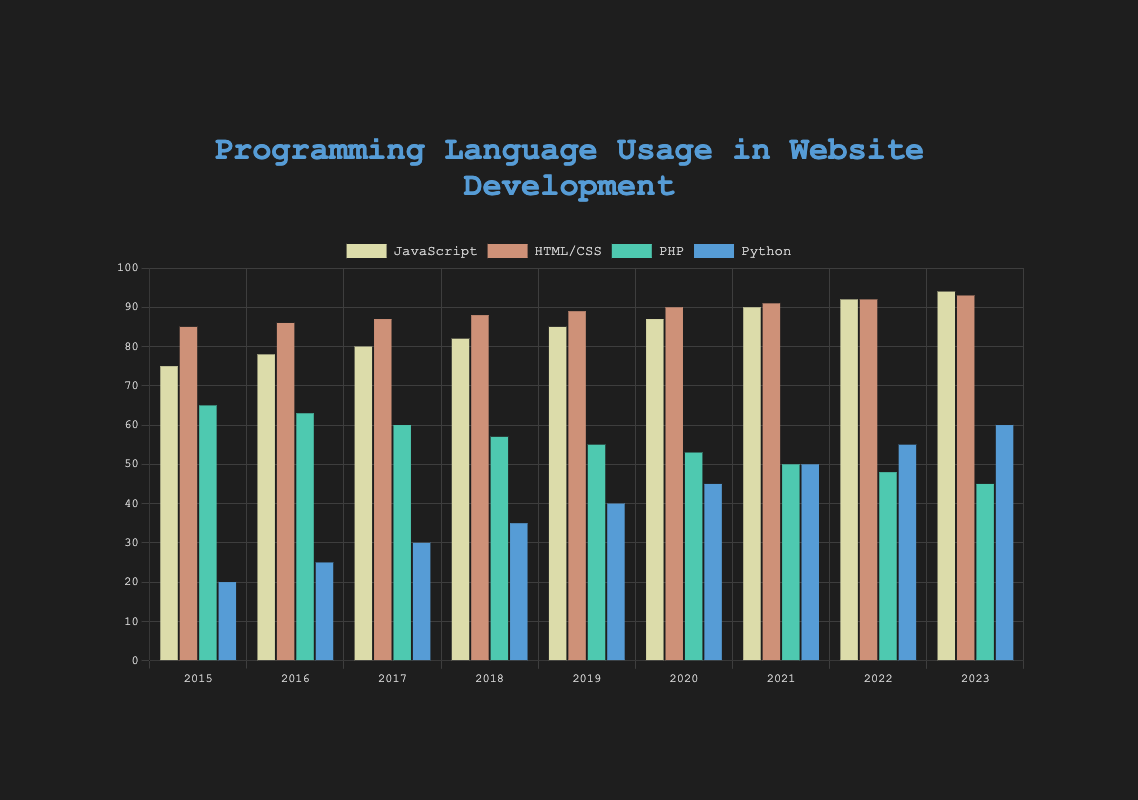What percentage of usage does JavaScript reach in 2023? In 2023, the bar representing JavaScript shows a usage percentage of 94%.
Answer: 94% How did PHP usage change from 2015 to 2023? The PHP usage in 2015 was 65%. In 2023, it decreased to 45%. Therefore, the decrease in PHP usage from 2015 to 2023 is 65% - 45% = 20%.
Answer: Decreased by 20% Between which consecutive years did Python usage see the largest increase? The Python usage increased by 5% each year from 20% in 2015 to 60% in 2023. Between 2020 and 2021, and 2021 and 2022, the increase was consistent at 5%. Thus, each consecutive year saw an equal largest increase of 5%.
Answer: 2015-2016, 2016-2017, 2017-2018, 2018-2019, 2019-2020, 2020-2021, 2021-2022, 2022-2023 (all had equal largest increase) Which language had the highest usage in 2021? In 2021, the heights of the bars show that HTML/CSS had the highest usage at 91%, followed by JavaScript at 90%, PHP at 50%, and Python at 50%. Therefore, HTML/CSS had the highest usage.
Answer: HTML/CSS What is the average usage of JavaScript from 2015 to 2023? To find the average, sum up the JavaScript usage percentages from 2015 to 2023: (75 + 78 + 80 + 82 + 85 + 87 + 90 + 92 + 94) = 763. Now, divide by the number of years (9). The average is 763 / 9 ≈ 84.78%.
Answer: 84.78% How does the usage of HTML/CSS compare between 2015 and 2020? In 2015, HTML/CSS usage was 85%, and in 2020, it increased to 90%. Thus, HTML/CSS usage increased by 90% - 85% = 5% from 2015 to 2020.
Answer: Increased by 5% Which programming language had the least usage in most of the years? By visually inspecting the heights of the bars from 2015 to 2023, it's evident that Python had the least usage in most years until it surpassed PHP usage starting from 2019 onwards.
Answer: Python What is the total usage of all languages combined in 2022? Sum up the percentages for JavaScript, HTML/CSS, PHP, and Python in 2022: 92% + 92% + 48% + 55% = 287%.
Answer: 287% What is the difference in usage between HTML/CSS and Python in 2017? In 2017, HTML/CSS usage was 87%, and Python usage was 30%. The difference is 87% - 30% = 57%.
Answer: 57% Which year did JavaScript surpass 90% usage? Looking at the bars, JavaScript surpassed 90% usage in 2021 when it reached 90%.
Answer: 2021 